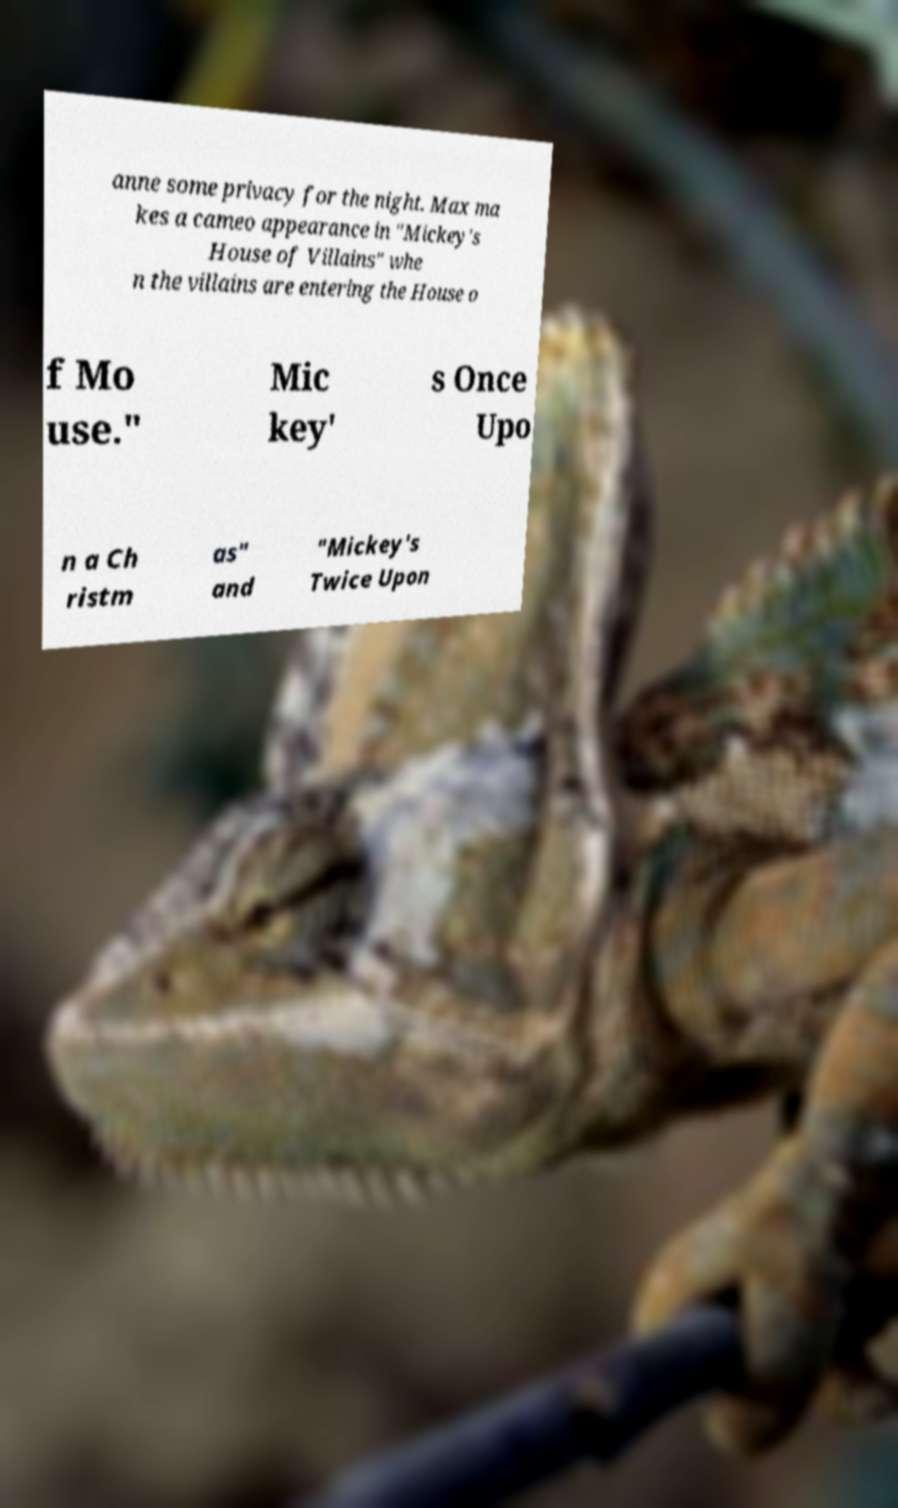Can you accurately transcribe the text from the provided image for me? anne some privacy for the night. Max ma kes a cameo appearance in "Mickey's House of Villains" whe n the villains are entering the House o f Mo use." Mic key' s Once Upo n a Ch ristm as" and "Mickey's Twice Upon 